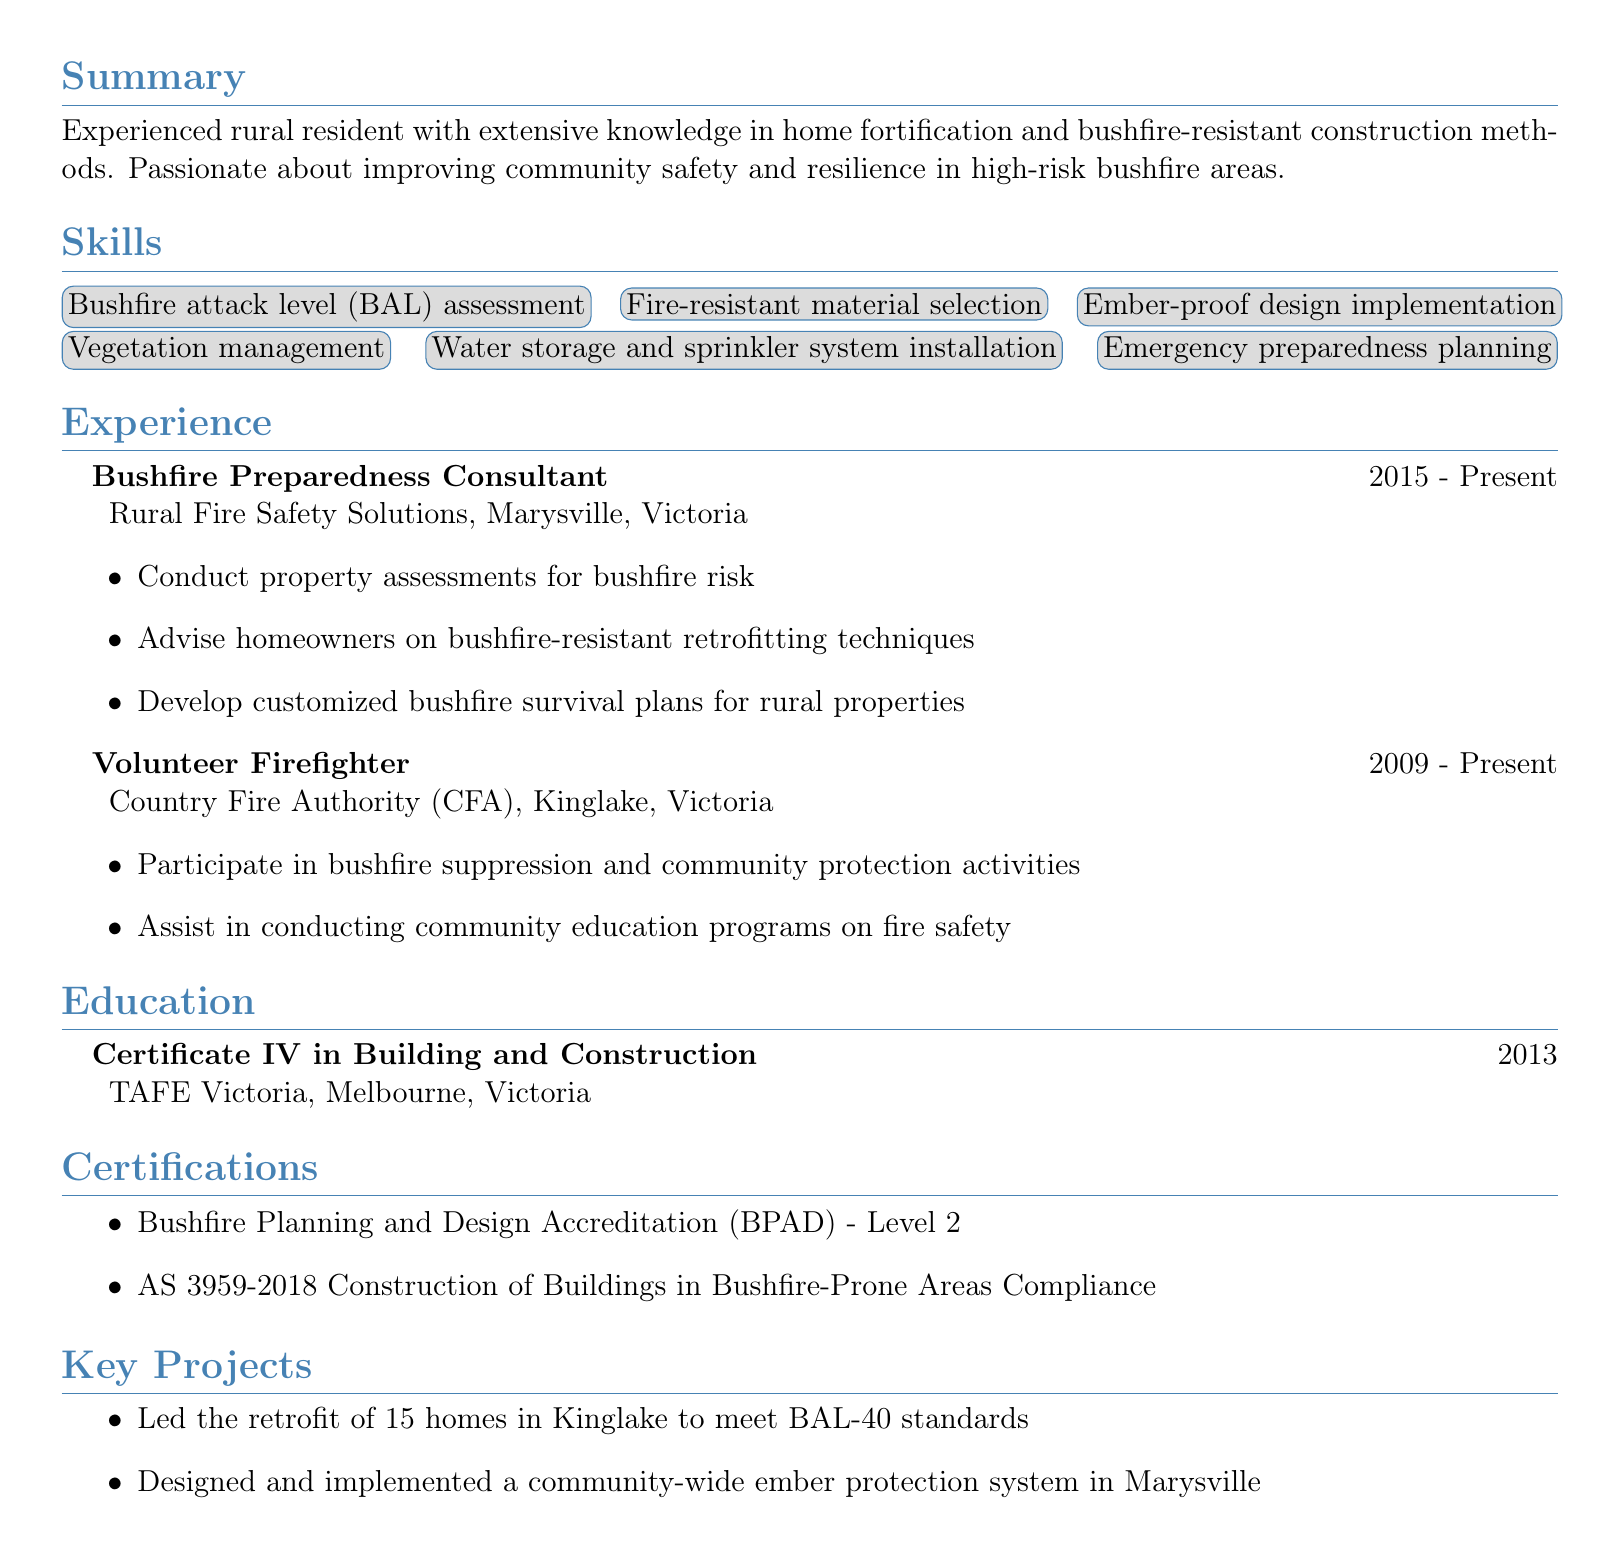What is the name of the applicant? The name of the applicant is clearly stated in the personal information section of the document.
Answer: Sarah Thompson Where does Sarah Thompson live? The location of Sarah Thompson is mentioned in the personal information section of the document.
Answer: Kinglake, Victoria What degree does Sarah hold? The education section provides information on the degree obtained by Sarah.
Answer: Certificate IV in Building and Construction How many years has Sarah worked as a Bushfire Preparedness Consultant? The experience section provides the starting year of Sarah's current role, allowing for calculation of years worked.
Answer: 8 years What is one of Sarah's skills related to fire safety? The skills section lists specific abilities of Sarah related to bushfire safety.
Answer: Ember-proof design implementation What organization has Sarah been a volunteer firefighter for? The experience section includes the organization where Sarah volunteers.
Answer: Country Fire Authority (CFA) In which year did Sarah complete her Certificate IV? The education section specifies the year Sarah completed her certificate.
Answer: 2013 What project did Sarah lead involving home retrofitting? The projects section outlines a specific project Sarah led regarding home retrofitting for bushfire standards.
Answer: Retrofit of 15 homes to meet BAL-40 standards Which accreditation does Sarah hold at Level 2? The certifications section lists specific credentials held by Sarah, including the accreditation mentioned.
Answer: Bushfire Planning and Design Accreditation (BPAD) 